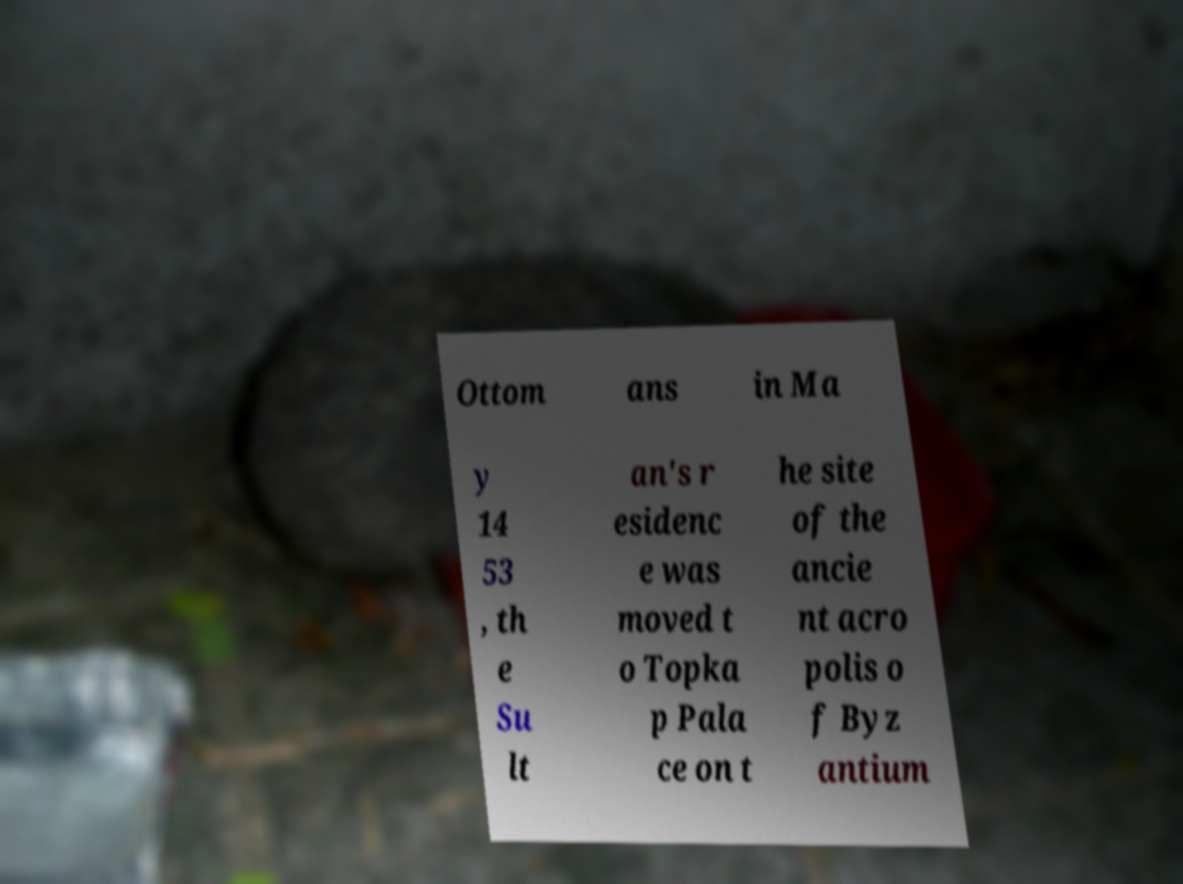Can you accurately transcribe the text from the provided image for me? Ottom ans in Ma y 14 53 , th e Su lt an's r esidenc e was moved t o Topka p Pala ce on t he site of the ancie nt acro polis o f Byz antium 